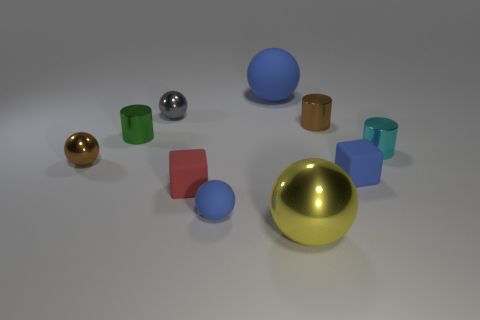Subtract all yellow balls. How many balls are left? 4 Subtract all red balls. Subtract all green cubes. How many balls are left? 5 Subtract all blocks. How many objects are left? 8 Subtract all gray spheres. Subtract all small cylinders. How many objects are left? 6 Add 9 blue matte cubes. How many blue matte cubes are left? 10 Add 2 big blue spheres. How many big blue spheres exist? 3 Subtract 0 green balls. How many objects are left? 10 